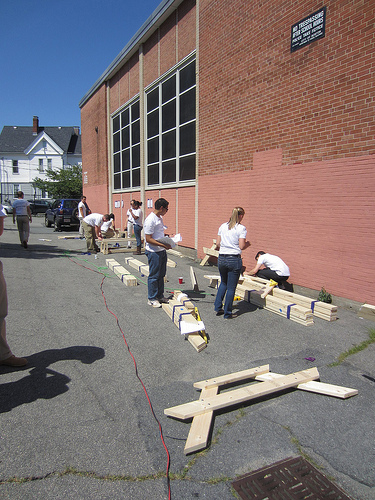<image>
Is there a woman next to the man? Yes. The woman is positioned adjacent to the man, located nearby in the same general area. 